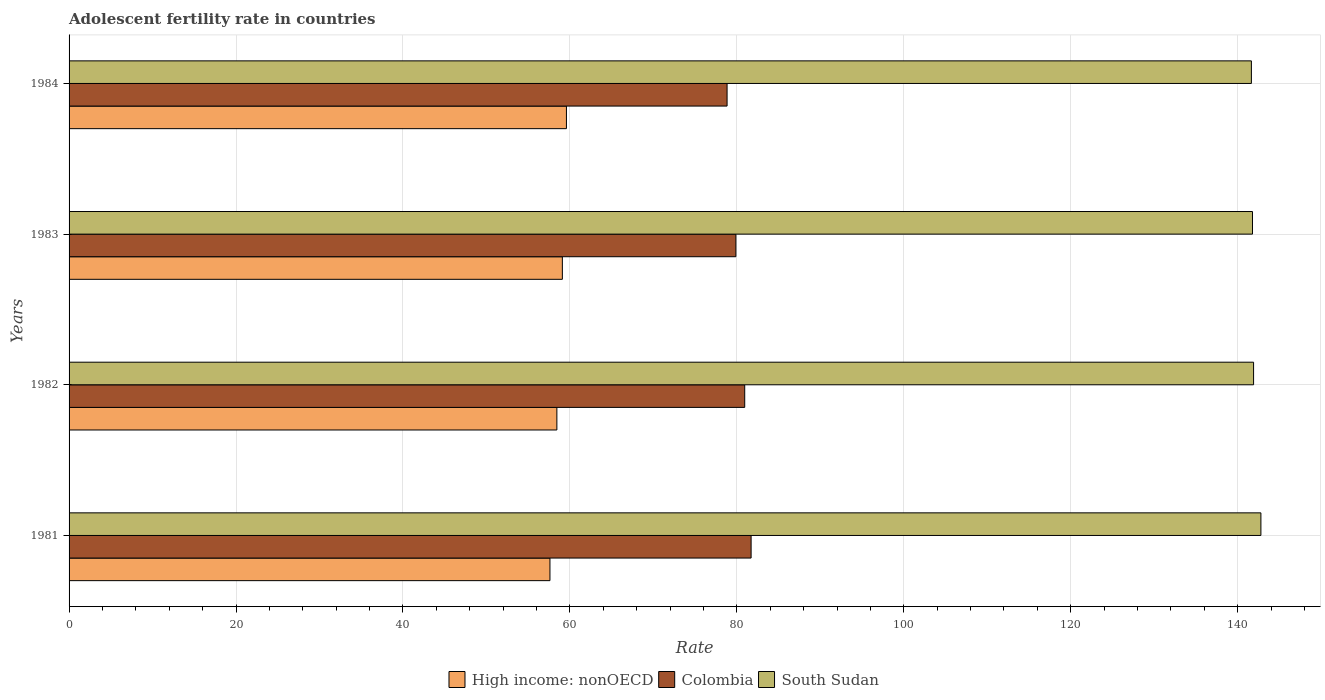How many different coloured bars are there?
Your answer should be very brief. 3. How many groups of bars are there?
Keep it short and to the point. 4. Are the number of bars per tick equal to the number of legend labels?
Keep it short and to the point. Yes. How many bars are there on the 3rd tick from the top?
Your answer should be very brief. 3. What is the label of the 3rd group of bars from the top?
Offer a very short reply. 1982. What is the adolescent fertility rate in South Sudan in 1984?
Provide a short and direct response. 141.64. Across all years, what is the maximum adolescent fertility rate in South Sudan?
Your answer should be very brief. 142.78. Across all years, what is the minimum adolescent fertility rate in High income: nonOECD?
Make the answer very short. 57.61. In which year was the adolescent fertility rate in Colombia maximum?
Ensure brevity in your answer.  1981. In which year was the adolescent fertility rate in South Sudan minimum?
Provide a succinct answer. 1984. What is the total adolescent fertility rate in Colombia in the graph?
Provide a succinct answer. 321.36. What is the difference between the adolescent fertility rate in South Sudan in 1982 and that in 1983?
Your answer should be very brief. 0.13. What is the difference between the adolescent fertility rate in High income: nonOECD in 1981 and the adolescent fertility rate in Colombia in 1983?
Offer a terse response. -22.28. What is the average adolescent fertility rate in South Sudan per year?
Provide a succinct answer. 142.02. In the year 1983, what is the difference between the adolescent fertility rate in Colombia and adolescent fertility rate in South Sudan?
Provide a short and direct response. -61.89. In how many years, is the adolescent fertility rate in Colombia greater than 8 ?
Your response must be concise. 4. What is the ratio of the adolescent fertility rate in South Sudan in 1981 to that in 1983?
Provide a short and direct response. 1.01. Is the adolescent fertility rate in High income: nonOECD in 1981 less than that in 1982?
Your answer should be compact. Yes. What is the difference between the highest and the second highest adolescent fertility rate in High income: nonOECD?
Keep it short and to the point. 0.49. What is the difference between the highest and the lowest adolescent fertility rate in High income: nonOECD?
Your answer should be very brief. 1.98. In how many years, is the adolescent fertility rate in High income: nonOECD greater than the average adolescent fertility rate in High income: nonOECD taken over all years?
Provide a short and direct response. 2. What does the 3rd bar from the top in 1981 represents?
Provide a short and direct response. High income: nonOECD. What does the 3rd bar from the bottom in 1981 represents?
Offer a very short reply. South Sudan. Is it the case that in every year, the sum of the adolescent fertility rate in Colombia and adolescent fertility rate in South Sudan is greater than the adolescent fertility rate in High income: nonOECD?
Provide a short and direct response. Yes. Are all the bars in the graph horizontal?
Ensure brevity in your answer.  Yes. What is the difference between two consecutive major ticks on the X-axis?
Offer a terse response. 20. Are the values on the major ticks of X-axis written in scientific E-notation?
Your answer should be compact. No. Does the graph contain any zero values?
Offer a terse response. No. Where does the legend appear in the graph?
Make the answer very short. Bottom center. How many legend labels are there?
Ensure brevity in your answer.  3. How are the legend labels stacked?
Provide a succinct answer. Horizontal. What is the title of the graph?
Ensure brevity in your answer.  Adolescent fertility rate in countries. What is the label or title of the X-axis?
Offer a terse response. Rate. What is the label or title of the Y-axis?
Your answer should be compact. Years. What is the Rate of High income: nonOECD in 1981?
Your response must be concise. 57.61. What is the Rate in Colombia in 1981?
Keep it short and to the point. 81.71. What is the Rate of South Sudan in 1981?
Offer a terse response. 142.78. What is the Rate in High income: nonOECD in 1982?
Give a very brief answer. 58.44. What is the Rate in Colombia in 1982?
Ensure brevity in your answer.  80.94. What is the Rate in South Sudan in 1982?
Offer a very short reply. 141.9. What is the Rate in High income: nonOECD in 1983?
Your response must be concise. 59.09. What is the Rate of Colombia in 1983?
Your response must be concise. 79.88. What is the Rate in South Sudan in 1983?
Provide a succinct answer. 141.77. What is the Rate in High income: nonOECD in 1984?
Ensure brevity in your answer.  59.58. What is the Rate of Colombia in 1984?
Provide a short and direct response. 78.83. What is the Rate of South Sudan in 1984?
Make the answer very short. 141.64. Across all years, what is the maximum Rate of High income: nonOECD?
Give a very brief answer. 59.58. Across all years, what is the maximum Rate of Colombia?
Provide a short and direct response. 81.71. Across all years, what is the maximum Rate of South Sudan?
Your response must be concise. 142.78. Across all years, what is the minimum Rate in High income: nonOECD?
Ensure brevity in your answer.  57.61. Across all years, what is the minimum Rate of Colombia?
Make the answer very short. 78.83. Across all years, what is the minimum Rate in South Sudan?
Keep it short and to the point. 141.64. What is the total Rate of High income: nonOECD in the graph?
Your answer should be very brief. 234.72. What is the total Rate in Colombia in the graph?
Offer a terse response. 321.36. What is the total Rate in South Sudan in the graph?
Ensure brevity in your answer.  568.08. What is the difference between the Rate in High income: nonOECD in 1981 and that in 1982?
Your response must be concise. -0.83. What is the difference between the Rate in Colombia in 1981 and that in 1982?
Offer a terse response. 0.77. What is the difference between the Rate of South Sudan in 1981 and that in 1982?
Provide a short and direct response. 0.88. What is the difference between the Rate of High income: nonOECD in 1981 and that in 1983?
Keep it short and to the point. -1.49. What is the difference between the Rate of Colombia in 1981 and that in 1983?
Keep it short and to the point. 1.82. What is the difference between the Rate of South Sudan in 1981 and that in 1983?
Offer a very short reply. 1.01. What is the difference between the Rate in High income: nonOECD in 1981 and that in 1984?
Your response must be concise. -1.98. What is the difference between the Rate in Colombia in 1981 and that in 1984?
Offer a terse response. 2.88. What is the difference between the Rate of South Sudan in 1981 and that in 1984?
Provide a succinct answer. 1.14. What is the difference between the Rate in High income: nonOECD in 1982 and that in 1983?
Offer a very short reply. -0.66. What is the difference between the Rate of Colombia in 1982 and that in 1983?
Provide a short and direct response. 1.06. What is the difference between the Rate in South Sudan in 1982 and that in 1983?
Your answer should be very brief. 0.13. What is the difference between the Rate of High income: nonOECD in 1982 and that in 1984?
Ensure brevity in your answer.  -1.15. What is the difference between the Rate of Colombia in 1982 and that in 1984?
Provide a short and direct response. 2.11. What is the difference between the Rate in South Sudan in 1982 and that in 1984?
Make the answer very short. 0.26. What is the difference between the Rate of High income: nonOECD in 1983 and that in 1984?
Provide a short and direct response. -0.49. What is the difference between the Rate of Colombia in 1983 and that in 1984?
Your response must be concise. 1.06. What is the difference between the Rate of South Sudan in 1983 and that in 1984?
Ensure brevity in your answer.  0.13. What is the difference between the Rate in High income: nonOECD in 1981 and the Rate in Colombia in 1982?
Your answer should be compact. -23.33. What is the difference between the Rate of High income: nonOECD in 1981 and the Rate of South Sudan in 1982?
Ensure brevity in your answer.  -84.29. What is the difference between the Rate in Colombia in 1981 and the Rate in South Sudan in 1982?
Ensure brevity in your answer.  -60.19. What is the difference between the Rate in High income: nonOECD in 1981 and the Rate in Colombia in 1983?
Provide a succinct answer. -22.28. What is the difference between the Rate of High income: nonOECD in 1981 and the Rate of South Sudan in 1983?
Make the answer very short. -84.16. What is the difference between the Rate in Colombia in 1981 and the Rate in South Sudan in 1983?
Give a very brief answer. -60.06. What is the difference between the Rate of High income: nonOECD in 1981 and the Rate of Colombia in 1984?
Your answer should be compact. -21.22. What is the difference between the Rate of High income: nonOECD in 1981 and the Rate of South Sudan in 1984?
Provide a succinct answer. -84.03. What is the difference between the Rate of Colombia in 1981 and the Rate of South Sudan in 1984?
Offer a terse response. -59.93. What is the difference between the Rate in High income: nonOECD in 1982 and the Rate in Colombia in 1983?
Make the answer very short. -21.45. What is the difference between the Rate in High income: nonOECD in 1982 and the Rate in South Sudan in 1983?
Keep it short and to the point. -83.33. What is the difference between the Rate of Colombia in 1982 and the Rate of South Sudan in 1983?
Ensure brevity in your answer.  -60.83. What is the difference between the Rate of High income: nonOECD in 1982 and the Rate of Colombia in 1984?
Your answer should be very brief. -20.39. What is the difference between the Rate in High income: nonOECD in 1982 and the Rate in South Sudan in 1984?
Provide a succinct answer. -83.2. What is the difference between the Rate in Colombia in 1982 and the Rate in South Sudan in 1984?
Provide a succinct answer. -60.7. What is the difference between the Rate of High income: nonOECD in 1983 and the Rate of Colombia in 1984?
Provide a succinct answer. -19.73. What is the difference between the Rate of High income: nonOECD in 1983 and the Rate of South Sudan in 1984?
Make the answer very short. -82.54. What is the difference between the Rate of Colombia in 1983 and the Rate of South Sudan in 1984?
Your answer should be very brief. -61.75. What is the average Rate in High income: nonOECD per year?
Ensure brevity in your answer.  58.68. What is the average Rate in Colombia per year?
Your answer should be very brief. 80.34. What is the average Rate in South Sudan per year?
Offer a terse response. 142.02. In the year 1981, what is the difference between the Rate of High income: nonOECD and Rate of Colombia?
Your response must be concise. -24.1. In the year 1981, what is the difference between the Rate in High income: nonOECD and Rate in South Sudan?
Keep it short and to the point. -85.17. In the year 1981, what is the difference between the Rate of Colombia and Rate of South Sudan?
Your answer should be very brief. -61.07. In the year 1982, what is the difference between the Rate in High income: nonOECD and Rate in Colombia?
Give a very brief answer. -22.5. In the year 1982, what is the difference between the Rate in High income: nonOECD and Rate in South Sudan?
Your answer should be very brief. -83.46. In the year 1982, what is the difference between the Rate in Colombia and Rate in South Sudan?
Provide a succinct answer. -60.96. In the year 1983, what is the difference between the Rate in High income: nonOECD and Rate in Colombia?
Keep it short and to the point. -20.79. In the year 1983, what is the difference between the Rate in High income: nonOECD and Rate in South Sudan?
Provide a short and direct response. -82.67. In the year 1983, what is the difference between the Rate in Colombia and Rate in South Sudan?
Your answer should be very brief. -61.88. In the year 1984, what is the difference between the Rate of High income: nonOECD and Rate of Colombia?
Provide a short and direct response. -19.24. In the year 1984, what is the difference between the Rate of High income: nonOECD and Rate of South Sudan?
Offer a terse response. -82.05. In the year 1984, what is the difference between the Rate in Colombia and Rate in South Sudan?
Provide a succinct answer. -62.81. What is the ratio of the Rate in High income: nonOECD in 1981 to that in 1982?
Offer a terse response. 0.99. What is the ratio of the Rate of Colombia in 1981 to that in 1982?
Give a very brief answer. 1.01. What is the ratio of the Rate of South Sudan in 1981 to that in 1982?
Make the answer very short. 1.01. What is the ratio of the Rate in High income: nonOECD in 1981 to that in 1983?
Your response must be concise. 0.97. What is the ratio of the Rate of Colombia in 1981 to that in 1983?
Your response must be concise. 1.02. What is the ratio of the Rate in South Sudan in 1981 to that in 1983?
Give a very brief answer. 1.01. What is the ratio of the Rate of High income: nonOECD in 1981 to that in 1984?
Your answer should be compact. 0.97. What is the ratio of the Rate in Colombia in 1981 to that in 1984?
Your answer should be very brief. 1.04. What is the ratio of the Rate of High income: nonOECD in 1982 to that in 1983?
Offer a terse response. 0.99. What is the ratio of the Rate in Colombia in 1982 to that in 1983?
Give a very brief answer. 1.01. What is the ratio of the Rate of High income: nonOECD in 1982 to that in 1984?
Offer a very short reply. 0.98. What is the ratio of the Rate in Colombia in 1982 to that in 1984?
Offer a terse response. 1.03. What is the ratio of the Rate in South Sudan in 1982 to that in 1984?
Your answer should be very brief. 1. What is the ratio of the Rate in High income: nonOECD in 1983 to that in 1984?
Give a very brief answer. 0.99. What is the ratio of the Rate in Colombia in 1983 to that in 1984?
Your response must be concise. 1.01. What is the difference between the highest and the second highest Rate of High income: nonOECD?
Provide a short and direct response. 0.49. What is the difference between the highest and the second highest Rate in Colombia?
Ensure brevity in your answer.  0.77. What is the difference between the highest and the second highest Rate of South Sudan?
Offer a very short reply. 0.88. What is the difference between the highest and the lowest Rate in High income: nonOECD?
Keep it short and to the point. 1.98. What is the difference between the highest and the lowest Rate of Colombia?
Your response must be concise. 2.88. What is the difference between the highest and the lowest Rate in South Sudan?
Offer a terse response. 1.14. 